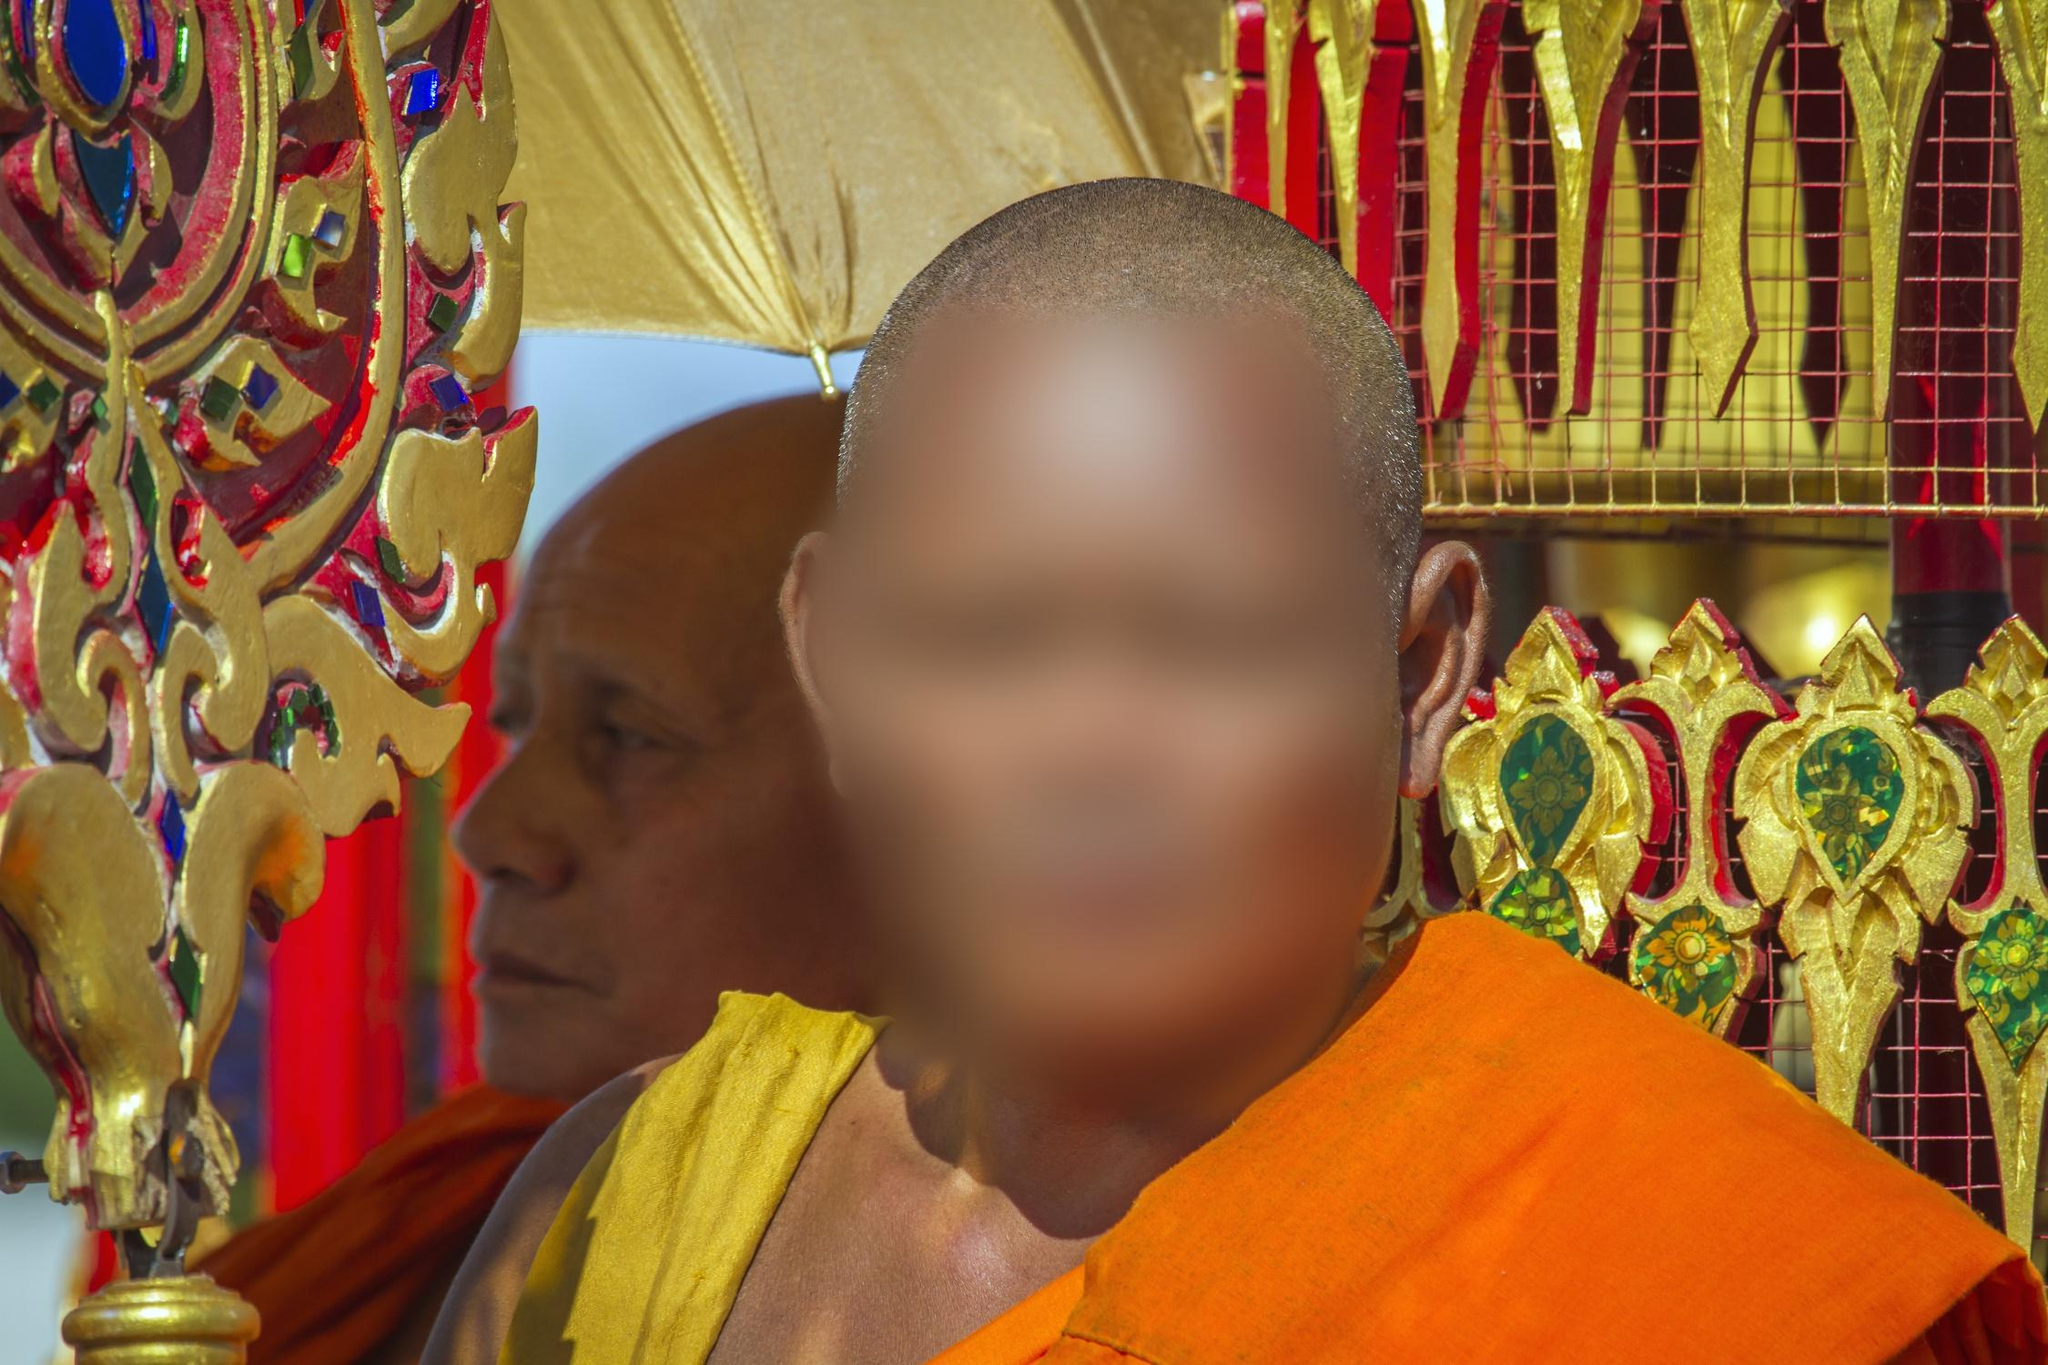What might be the significance of the golden artifact beside the monk? The golden artifact adorned with intricate carvings and jewels is likely a ceremonial urn or a container used in religious rituals. Such artifacts are often used to store sacred relics or offerings and are significant in many Buddhist ceremonies, emphasizing reverence and the belief in the sanctity of spiritual elements. Can you describe the event where this image might have been taken? This image could be taken during a significant religious festival or a daily ritual at the temple. The presence of ceremonial artifacts and the monks' solemn expressions suggest a moment of prayer or meditation, typical of events like Vesak, which celebrates the Buddha's birth, enlightenment, and death, or during daily rituals that focus on mindfulness and spiritual teachings. 